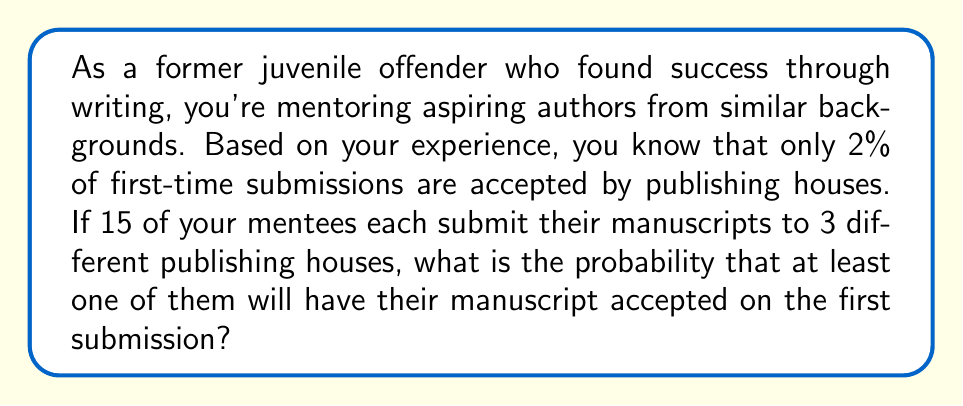Teach me how to tackle this problem. Let's approach this step-by-step:

1) First, let's calculate the probability of a single manuscript being rejected by all 3 publishing houses:
   
   Probability of rejection by one house = 1 - 0.02 = 0.98
   Probability of rejection by all 3 houses = $0.98^3 = 0.941192$

2) Now, the probability of at least one acceptance for a single mentee is the opposite of being rejected by all:
   
   Probability of at least one acceptance = $1 - 0.941192 = 0.058808$

3) For all 15 mentees, we want the probability that at least one of them has at least one acceptance. This is easier to calculate by finding the probability that none of them have an acceptance and then subtracting from 1:

   Probability of no acceptances for one mentee = $1 - 0.058808 = 0.941192$
   
   Probability of no acceptances for all 15 mentees = $0.941192^{15}$

4) Therefore, the probability of at least one mentee having at least one acceptance is:

   $P(\text{at least one acceptance}) = 1 - 0.941192^{15}$

5) Calculate the final answer:
   
   $1 - 0.941192^{15} = 1 - 0.409223 = 0.590777$
Answer: The probability that at least one of the 15 mentees will have their manuscript accepted on the first submission is approximately 0.5908 or 59.08%. 